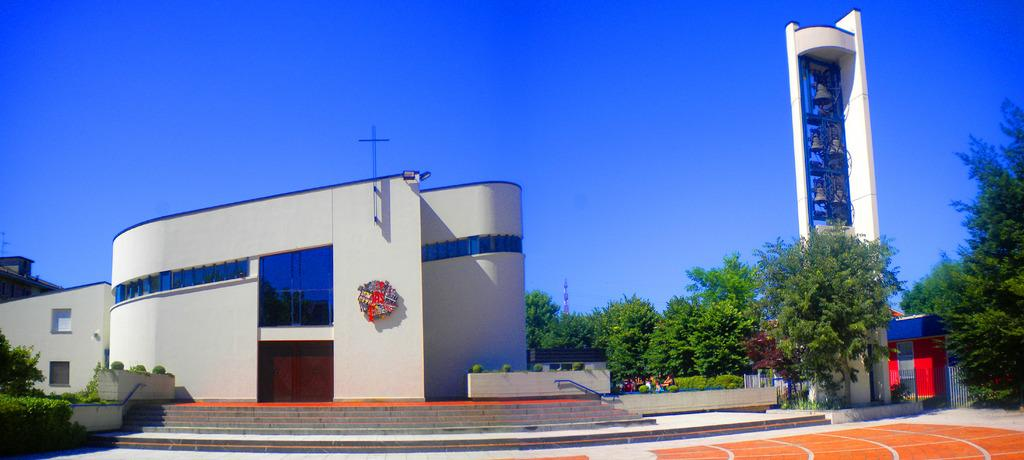What type of structure is visible in the image? There is a building in the image. What feature of the building is mentioned in the facts? The building has a door and steps. What other objects or features can be seen in the image? There are plants, a tower with bells, trees, and the sky is visible in the background. What type of badge is being offered to the nation in the image? There is no badge or nation mentioned in the image; it features a building with a door, steps, plants, a tower with bells, trees, and a visible sky. 